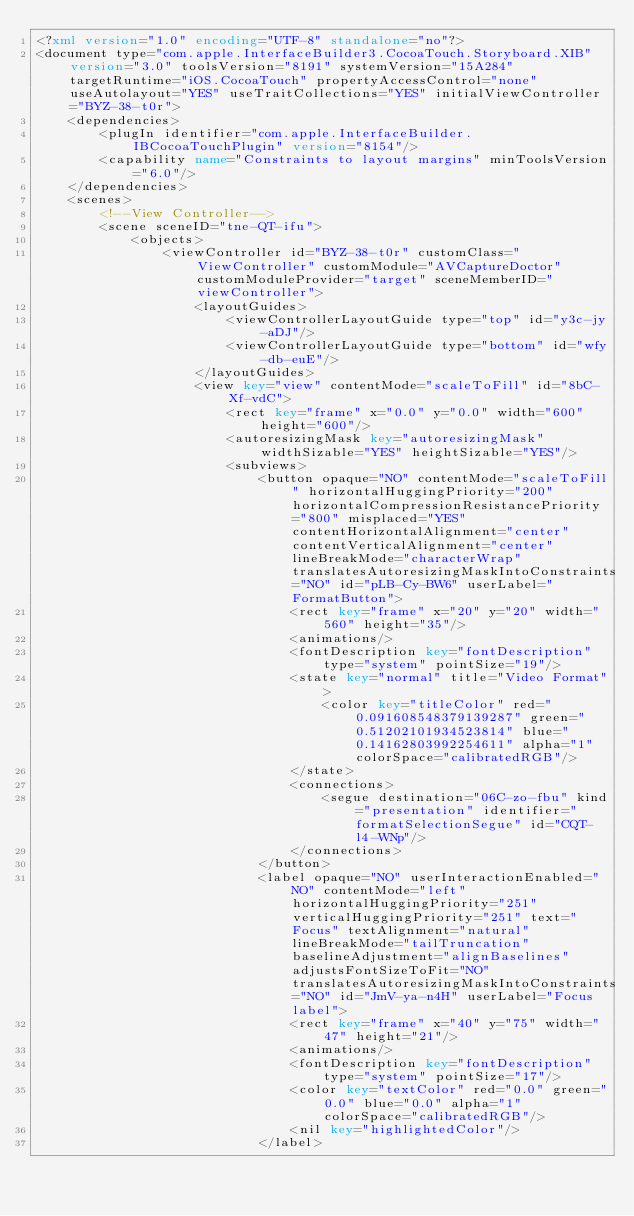<code> <loc_0><loc_0><loc_500><loc_500><_XML_><?xml version="1.0" encoding="UTF-8" standalone="no"?>
<document type="com.apple.InterfaceBuilder3.CocoaTouch.Storyboard.XIB" version="3.0" toolsVersion="8191" systemVersion="15A284" targetRuntime="iOS.CocoaTouch" propertyAccessControl="none" useAutolayout="YES" useTraitCollections="YES" initialViewController="BYZ-38-t0r">
    <dependencies>
        <plugIn identifier="com.apple.InterfaceBuilder.IBCocoaTouchPlugin" version="8154"/>
        <capability name="Constraints to layout margins" minToolsVersion="6.0"/>
    </dependencies>
    <scenes>
        <!--View Controller-->
        <scene sceneID="tne-QT-ifu">
            <objects>
                <viewController id="BYZ-38-t0r" customClass="ViewController" customModule="AVCaptureDoctor" customModuleProvider="target" sceneMemberID="viewController">
                    <layoutGuides>
                        <viewControllerLayoutGuide type="top" id="y3c-jy-aDJ"/>
                        <viewControllerLayoutGuide type="bottom" id="wfy-db-euE"/>
                    </layoutGuides>
                    <view key="view" contentMode="scaleToFill" id="8bC-Xf-vdC">
                        <rect key="frame" x="0.0" y="0.0" width="600" height="600"/>
                        <autoresizingMask key="autoresizingMask" widthSizable="YES" heightSizable="YES"/>
                        <subviews>
                            <button opaque="NO" contentMode="scaleToFill" horizontalHuggingPriority="200" horizontalCompressionResistancePriority="800" misplaced="YES" contentHorizontalAlignment="center" contentVerticalAlignment="center" lineBreakMode="characterWrap" translatesAutoresizingMaskIntoConstraints="NO" id="pLB-Cy-BW6" userLabel="FormatButton">
                                <rect key="frame" x="20" y="20" width="560" height="35"/>
                                <animations/>
                                <fontDescription key="fontDescription" type="system" pointSize="19"/>
                                <state key="normal" title="Video Format">
                                    <color key="titleColor" red="0.091608548379139287" green="0.51202101934523814" blue="0.14162803992254611" alpha="1" colorSpace="calibratedRGB"/>
                                </state>
                                <connections>
                                    <segue destination="06C-zo-fbu" kind="presentation" identifier="formatSelectionSegue" id="CQT-l4-WNp"/>
                                </connections>
                            </button>
                            <label opaque="NO" userInteractionEnabled="NO" contentMode="left" horizontalHuggingPriority="251" verticalHuggingPriority="251" text="Focus" textAlignment="natural" lineBreakMode="tailTruncation" baselineAdjustment="alignBaselines" adjustsFontSizeToFit="NO" translatesAutoresizingMaskIntoConstraints="NO" id="JmV-ya-n4H" userLabel="Focus label">
                                <rect key="frame" x="40" y="75" width="47" height="21"/>
                                <animations/>
                                <fontDescription key="fontDescription" type="system" pointSize="17"/>
                                <color key="textColor" red="0.0" green="0.0" blue="0.0" alpha="1" colorSpace="calibratedRGB"/>
                                <nil key="highlightedColor"/>
                            </label></code> 